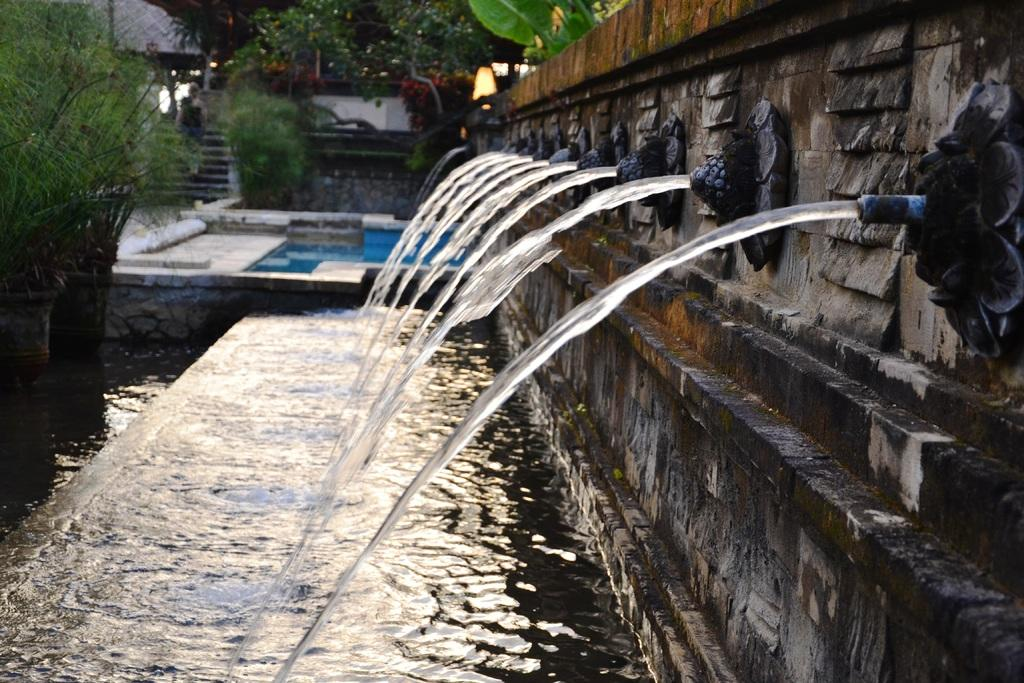What is happening in the image? Water is flowing in the image. What can be seen on the right side of the image? There is a wall on the right side of the image. What type of vegetation is on the left side of the image? There are trees on the left side of the image. What type of seed is growing in the mitten on the left side of the image? There is no seed or mitten present in the image; it features flowing water and a wall on the right side, as well as trees on the left side. 